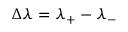<formula> <loc_0><loc_0><loc_500><loc_500>\Delta \lambda = \lambda _ { + } - \lambda _ { - }</formula> 